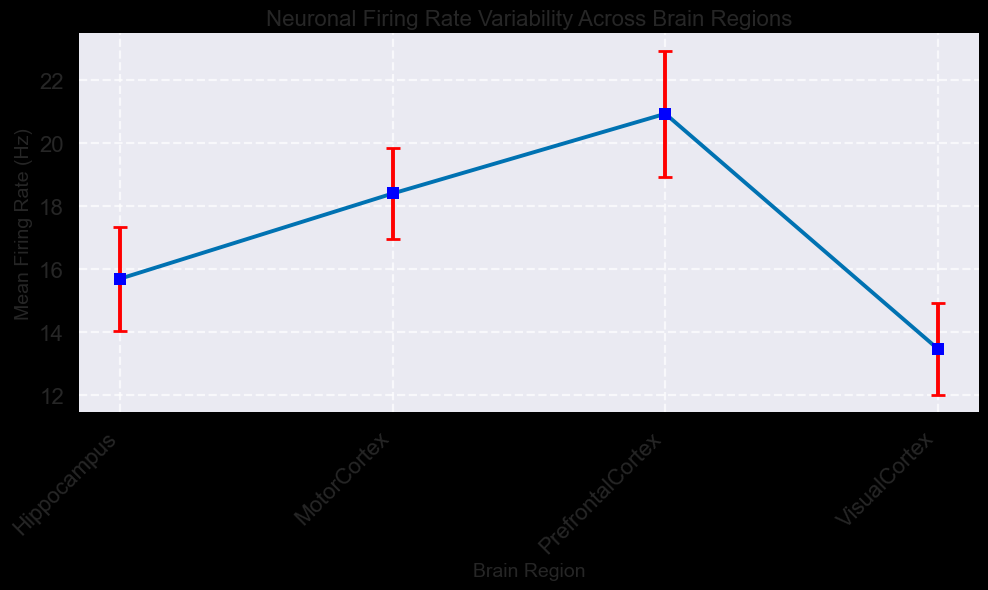Which brain region has the highest mean firing rate? Observe the highest point on the y-axis and identify that it corresponds to the Prefrontal Cortex.
Answer: Prefrontal Cortex Which brain region has the lowest mean firing rate? Look for the lowest point on the y-axis and see that it corresponds to the Visual Cortex.
Answer: Visual Cortex How does the mean firing rate of the Motor Cortex compare to the Hippocampus? Compare the height of the mean firing rates of the two regions. The Motor Cortex has a higher mean rate than the Hippocampus.
Answer: Motor Cortex is higher What is the difference in mean firing rate between the Prefrontal Cortex and the Visual Cortex? Subtract the mean firing rate of the Visual Cortex from that of the Prefrontal Cortex (about 20.93 Hz - 13.48 Hz).
Answer: 7.45 Hz Which brain region shows the highest variability in firing rates based on the error bars? Look for the brain region with the longest error bars. The Prefrontal Cortex has the longest error bars.
Answer: Prefrontal Cortex Rank the brain regions based on their mean firing rates from highest to lowest. Order the regions by mean firing rate: Prefrontal Cortex > Motor Cortex > Hippocampus > Visual Cortex.
Answer: Prefrontal Cortex, Motor Cortex, Hippocampus, Visual Cortex Is the mean firing rate of the Motor Cortex equal to that of the Prefrontal Cortex? The mean firing rate of the Motor Cortex is lower than that of the Prefrontal Cortex by visual inspection.
Answer: No What is the mean firing rate of the Hippocampus and Visual Cortex combined? Add the mean firing rates of the Hippocampus and Visual Cortex (15.7 Hz + 13.5 Hz).
Answer: 29.2 Hz Considering the standard error, which brain region's mean firing rate is the most precise? The Visual Cortex has the smallest standard error, indicating the most precise mean firing rate observation.
Answer: Visual Cortex 